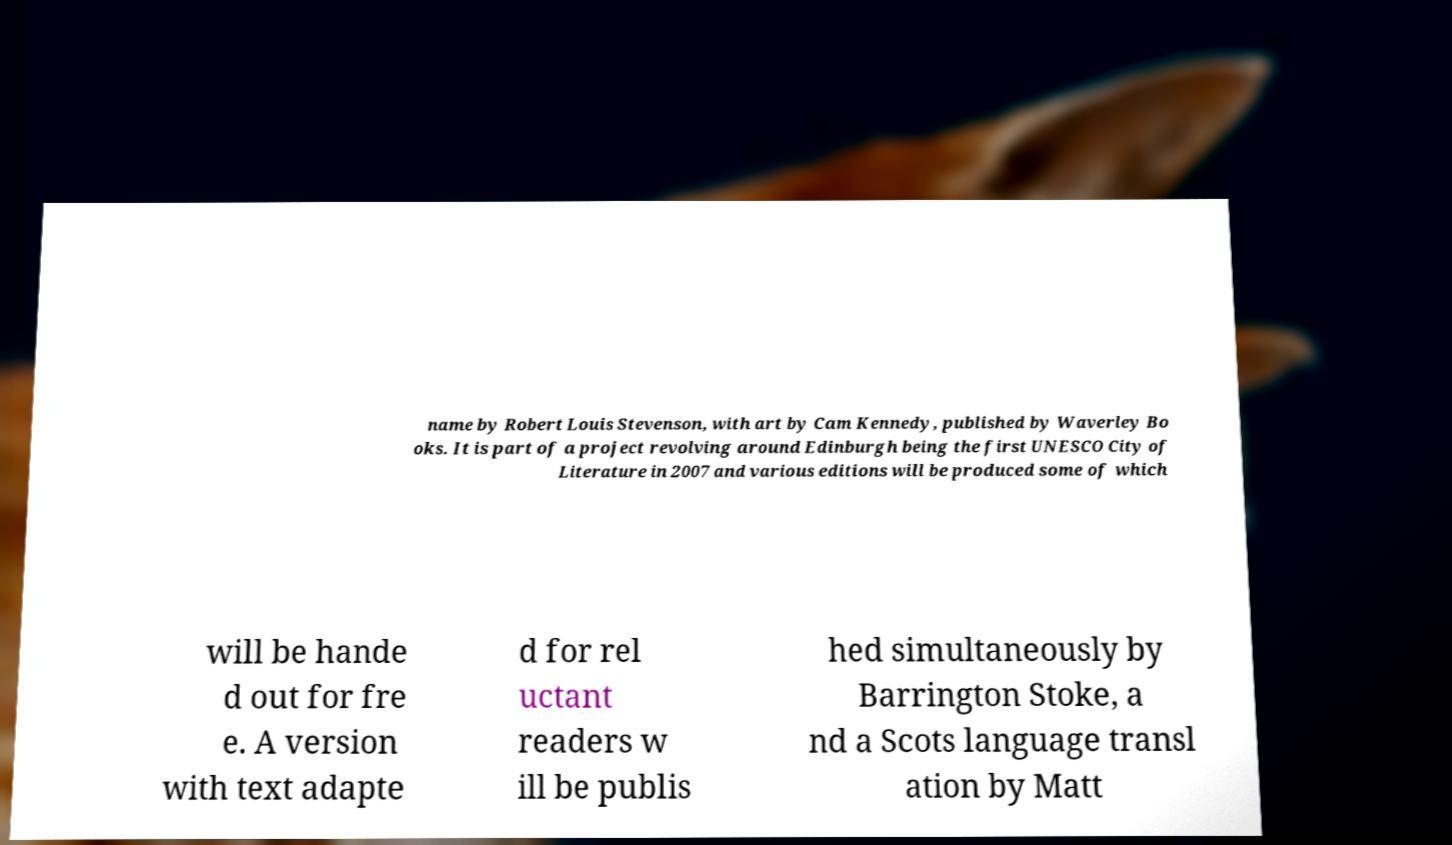Can you read and provide the text displayed in the image?This photo seems to have some interesting text. Can you extract and type it out for me? name by Robert Louis Stevenson, with art by Cam Kennedy, published by Waverley Bo oks. It is part of a project revolving around Edinburgh being the first UNESCO City of Literature in 2007 and various editions will be produced some of which will be hande d out for fre e. A version with text adapte d for rel uctant readers w ill be publis hed simultaneously by Barrington Stoke, a nd a Scots language transl ation by Matt 